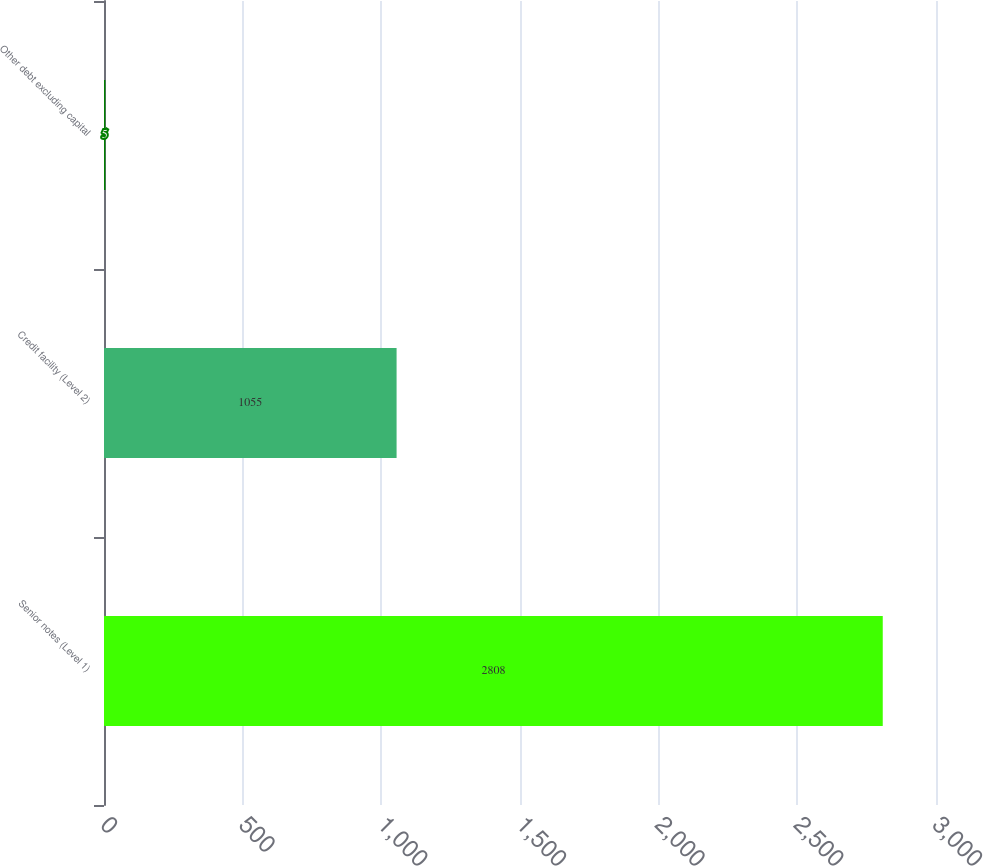<chart> <loc_0><loc_0><loc_500><loc_500><bar_chart><fcel>Senior notes (Level 1)<fcel>Credit facility (Level 2)<fcel>Other debt excluding capital<nl><fcel>2808<fcel>1055<fcel>5<nl></chart> 